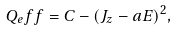Convert formula to latex. <formula><loc_0><loc_0><loc_500><loc_500>Q _ { e } f f = C - ( J _ { z } - a E ) ^ { 2 } ,</formula> 